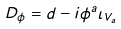Convert formula to latex. <formula><loc_0><loc_0><loc_500><loc_500>D _ { \phi } = d - i \phi ^ { a } \iota _ { V _ { a } }</formula> 